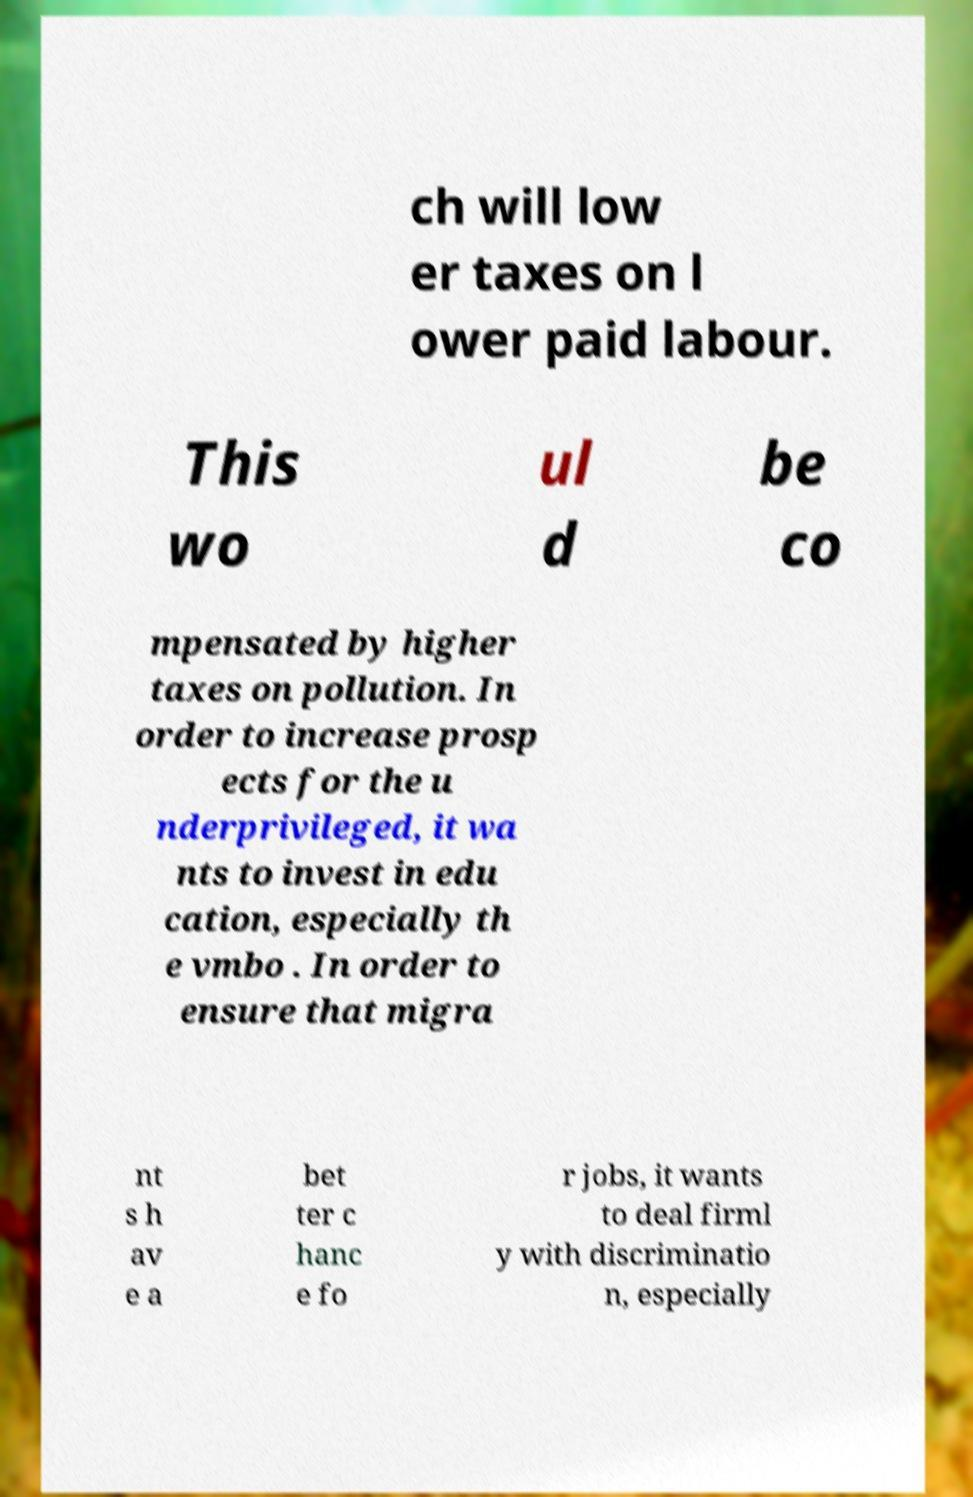Please identify and transcribe the text found in this image. ch will low er taxes on l ower paid labour. This wo ul d be co mpensated by higher taxes on pollution. In order to increase prosp ects for the u nderprivileged, it wa nts to invest in edu cation, especially th e vmbo . In order to ensure that migra nt s h av e a bet ter c hanc e fo r jobs, it wants to deal firml y with discriminatio n, especially 